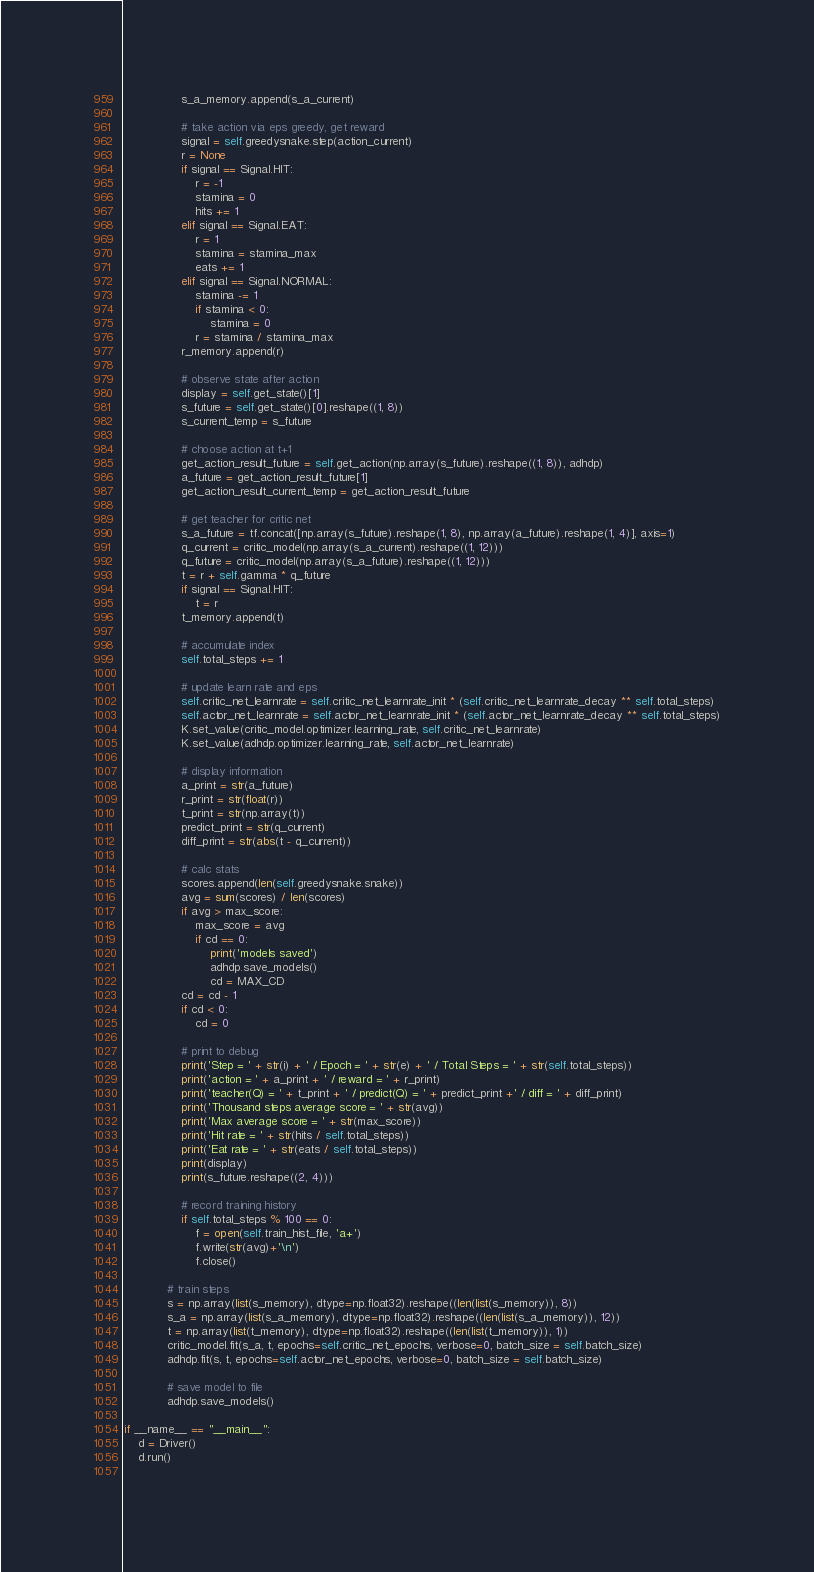Convert code to text. <code><loc_0><loc_0><loc_500><loc_500><_Python_>                s_a_memory.append(s_a_current)

                # take action via eps greedy, get reward
                signal = self.greedysnake.step(action_current)
                r = None
                if signal == Signal.HIT:
                    r = -1
                    stamina = 0
                    hits += 1
                elif signal == Signal.EAT:
                    r = 1
                    stamina = stamina_max
                    eats += 1
                elif signal == Signal.NORMAL:
                    stamina -= 1
                    if stamina < 0:
                        stamina = 0
                    r = stamina / stamina_max
                r_memory.append(r)

                # observe state after action
                display = self.get_state()[1]
                s_future = self.get_state()[0].reshape((1, 8))
                s_current_temp = s_future
                
                # choose action at t+1
                get_action_result_future = self.get_action(np.array(s_future).reshape((1, 8)), adhdp)
                a_future = get_action_result_future[1]
                get_action_result_current_temp = get_action_result_future

                # get teacher for critic net
                s_a_future = tf.concat([np.array(s_future).reshape(1, 8), np.array(a_future).reshape(1, 4)], axis=1)
                q_current = critic_model(np.array(s_a_current).reshape((1, 12)))
                q_future = critic_model(np.array(s_a_future).reshape((1, 12)))
                t = r + self.gamma * q_future
                if signal == Signal.HIT:
                    t = r
                t_memory.append(t)

                # accumulate index
                self.total_steps += 1

                # update learn rate and eps
                self.critic_net_learnrate = self.critic_net_learnrate_init * (self.critic_net_learnrate_decay ** self.total_steps)
                self.actor_net_learnrate = self.actor_net_learnrate_init * (self.actor_net_learnrate_decay ** self.total_steps)
                K.set_value(critic_model.optimizer.learning_rate, self.critic_net_learnrate)
                K.set_value(adhdp.optimizer.learning_rate, self.actor_net_learnrate)

                # display information
                a_print = str(a_future)
                r_print = str(float(r))
                t_print = str(np.array(t))
                predict_print = str(q_current)
                diff_print = str(abs(t - q_current))

                # calc stats
                scores.append(len(self.greedysnake.snake))
                avg = sum(scores) / len(scores)
                if avg > max_score:
                    max_score = avg
                    if cd == 0:
                        print('models saved')
                        adhdp.save_models()
                        cd = MAX_CD
                cd = cd - 1
                if cd < 0:
                    cd = 0
                    
                # print to debug
                print('Step = ' + str(i) + ' / Epoch = ' + str(e) + ' / Total Steps = ' + str(self.total_steps))
                print('action = ' + a_print + ' / reward = ' + r_print)
                print('teacher(Q) = ' + t_print + ' / predict(Q) = ' + predict_print +' / diff = ' + diff_print)
                print('Thousand steps average score = ' + str(avg))
                print('Max average score = ' + str(max_score))
                print('Hit rate = ' + str(hits / self.total_steps))
                print('Eat rate = ' + str(eats / self.total_steps))
                print(display)
                print(s_future.reshape((2, 4)))

                # record training history
                if self.total_steps % 100 == 0:
                    f = open(self.train_hist_file, 'a+')
                    f.write(str(avg)+'\n')
                    f.close()
                
            # train steps
            s = np.array(list(s_memory), dtype=np.float32).reshape((len(list(s_memory)), 8))
            s_a = np.array(list(s_a_memory), dtype=np.float32).reshape((len(list(s_a_memory)), 12))
            t = np.array(list(t_memory), dtype=np.float32).reshape((len(list(t_memory)), 1))
            critic_model.fit(s_a, t, epochs=self.critic_net_epochs, verbose=0, batch_size = self.batch_size)
            adhdp.fit(s, t, epochs=self.actor_net_epochs, verbose=0, batch_size = self.batch_size)

            # save model to file
            adhdp.save_models()

if __name__ == "__main__":
    d = Driver()
    d.run()
        
</code> 